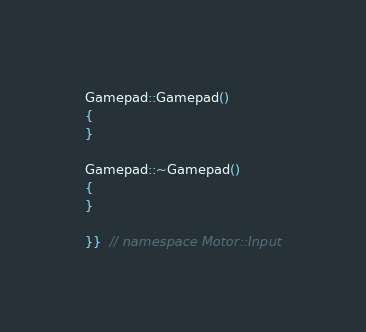<code> <loc_0><loc_0><loc_500><loc_500><_C++_>Gamepad::Gamepad()
{
}

Gamepad::~Gamepad()
{
}

}}  // namespace Motor::Input
</code> 